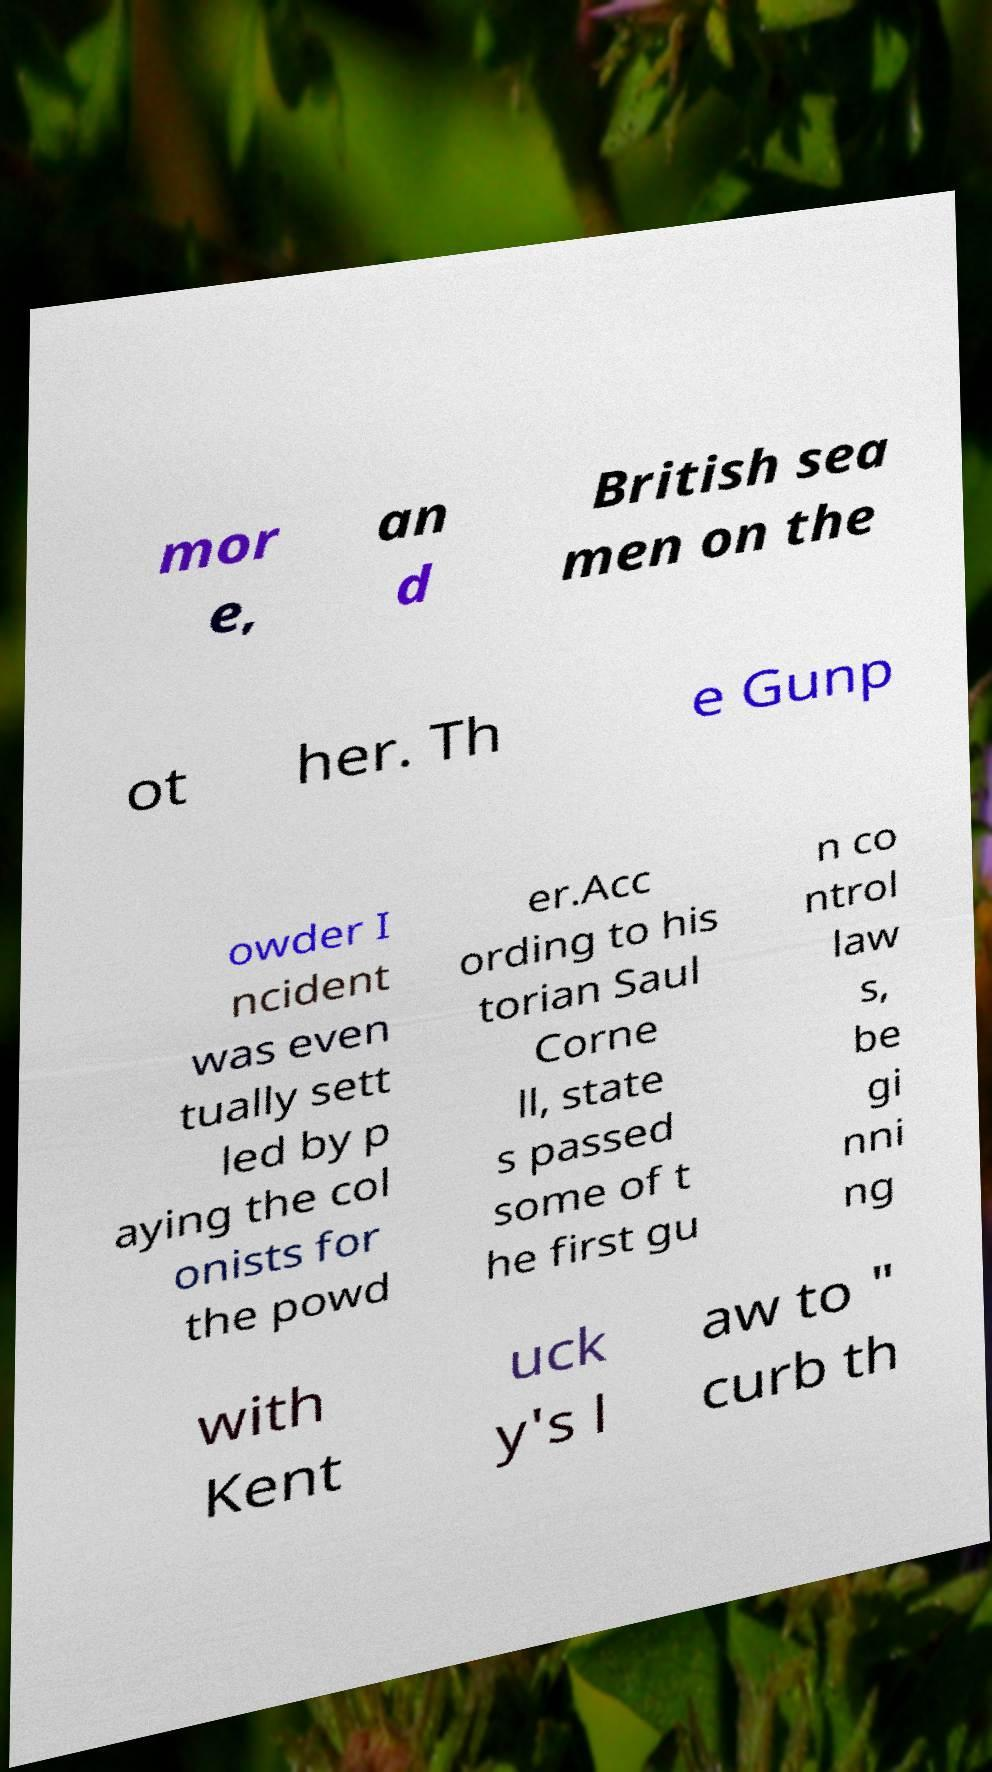Can you accurately transcribe the text from the provided image for me? mor e, an d British sea men on the ot her. Th e Gunp owder I ncident was even tually sett led by p aying the col onists for the powd er.Acc ording to his torian Saul Corne ll, state s passed some of t he first gu n co ntrol law s, be gi nni ng with Kent uck y's l aw to " curb th 